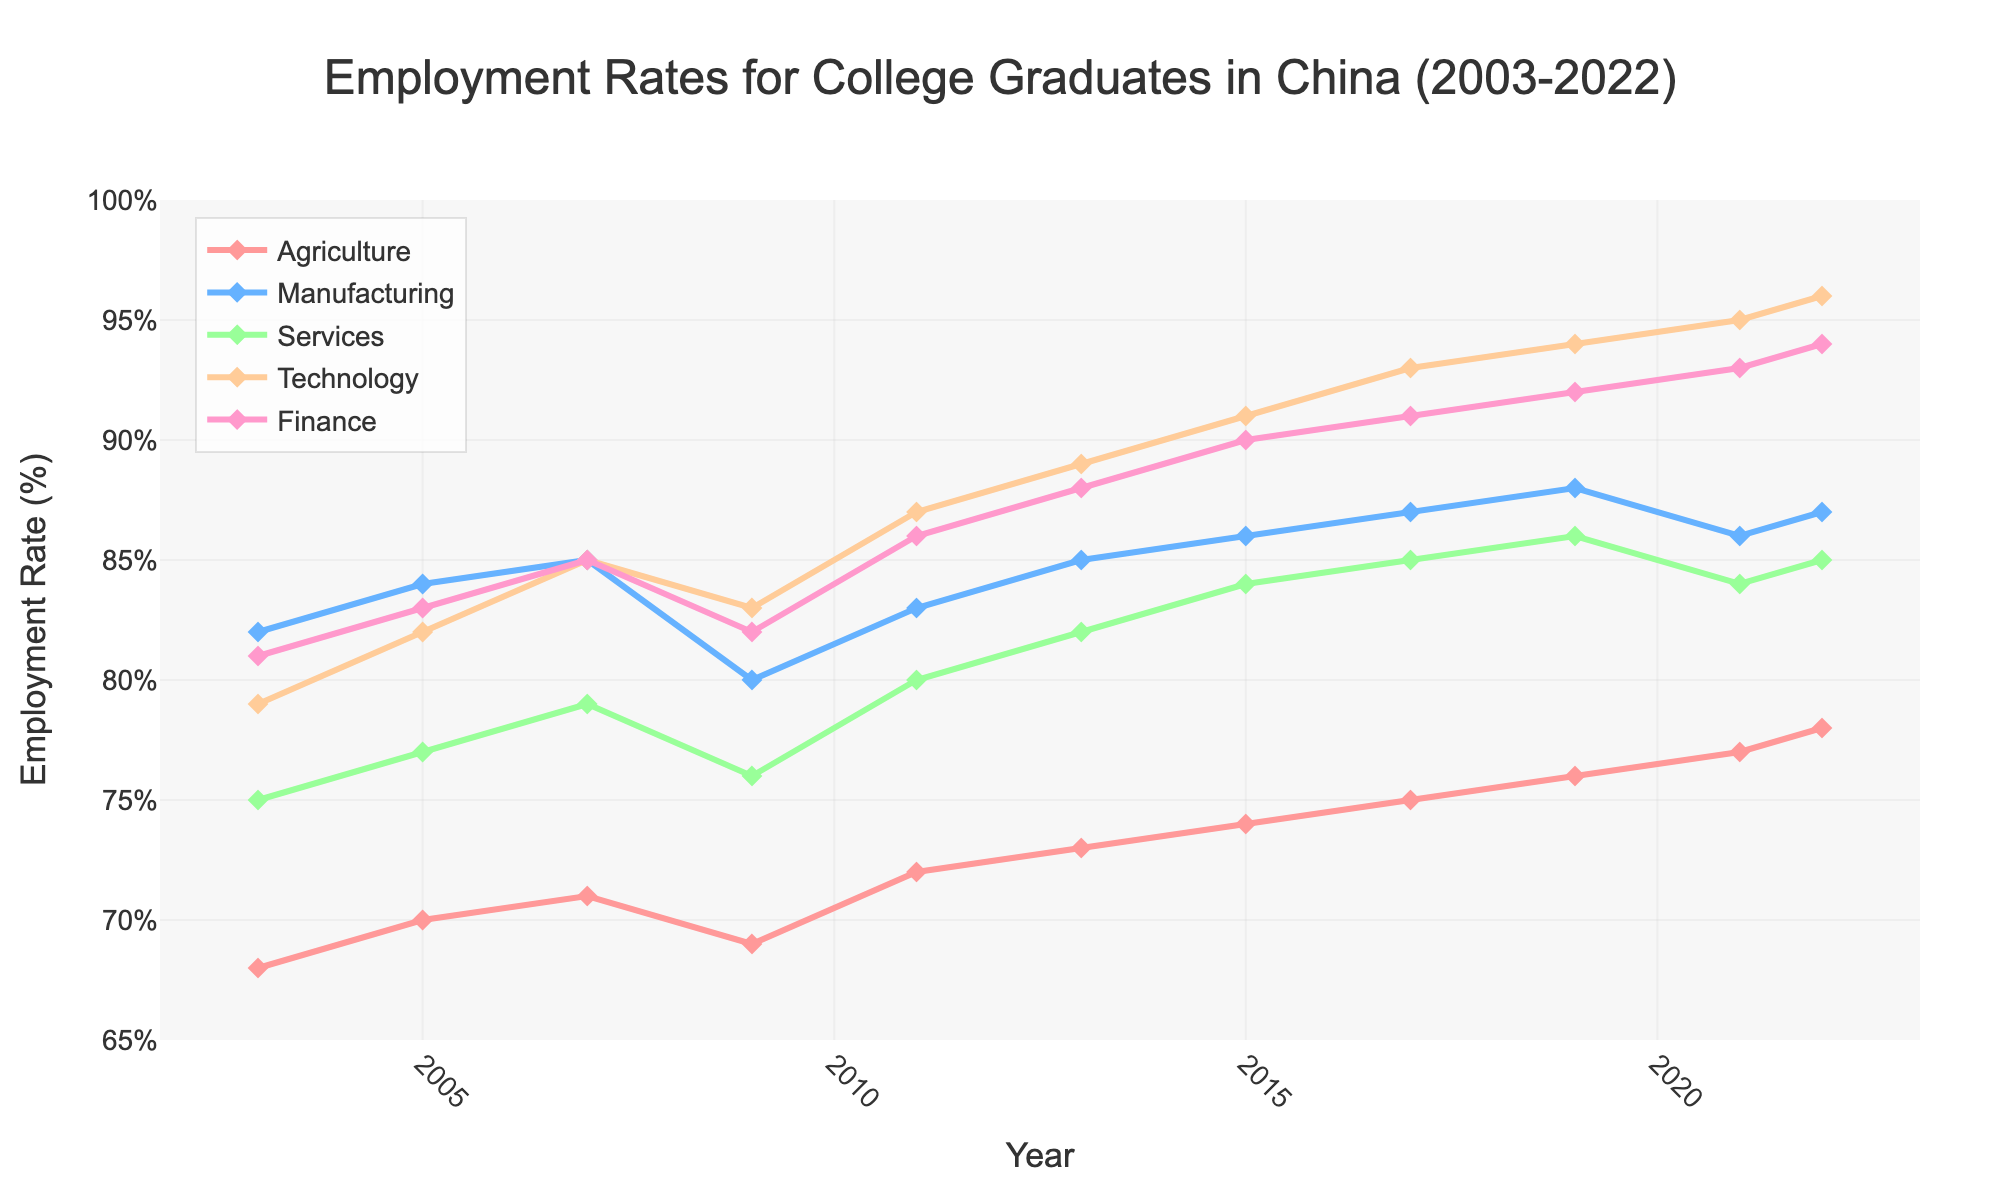What is the trend in employment rates in the Technology sector from 2003 to 2022? The line for the Technology sector shows a consistent upward trend from 79% in 2003 to 96% in 2022. This indicates a steady increase in employment rates over the years.
Answer: Upward trend Which sector had the highest employment rate in 2022? By comparing the heights of the lines at the year 2022, the Technology sector reached the highest employment rate at 96%.
Answer: Technology Between which years did the Services sector see the most significant increase in employment rate? Analyzing the slope of the lines for the Services sector, the most significant increase appears between 2009 (76%) and 2011 (80%), a 4 percentage point increase.
Answer: 2009 to 2011 How does the employment rate in Agriculture in 2022 compare to that in 2003? In 2003, the employment rate in Agriculture was 68%, and it increased to 78% in 2022. This is a difference of 10 percentage points.
Answer: Increased by 10 percentage points Across all sectors, which year shows the biggest dip in employment rates? Looking at the visual dips in the lines, 2009 shows a notable dip, especially in the Manufacturing sector, which drops from 85% in 2007 to 80% in 2009.
Answer: 2009 What is the average employment rate in the Finance sector from 2003 to 2022? Sum the Finance sector employment rates for each year and divide by the number of years: (81+83+85+82+86+88+90+91+92+93+94) / 11 = 89:63/11 = 82.7.
Answer: 87.5% Which sector had the least volatile employment rate over the years? By comparing the fluctuations in the lines, the Technology sector shows a steady and consistent increase with fewer fluctuations compared to other sectors.
Answer: Technology In which year did the Manufacturing sector experience the smallest employment rate? By tracing the Manufacturing line, the smallest employment rate is seen in 2009 at 80%.
Answer: 2009 What is the employment trend difference between the Agriculture and Finance sectors from 2003 to 2022? The Agriculture sector shows a gradual upward trend from 68% to 78%, a 10 percentage points increase. The Finance sector shows a steeper upward trend from 81% to 94%, a 13 percentage points increase.
Answer: Both upward, Finance is steeper How many sectors had an employment rate above 90% in 2022? By looking at the end points for 2022, both Technology (96%) and Finance (94%) had employment rates above 90%.
Answer: Two sectors 